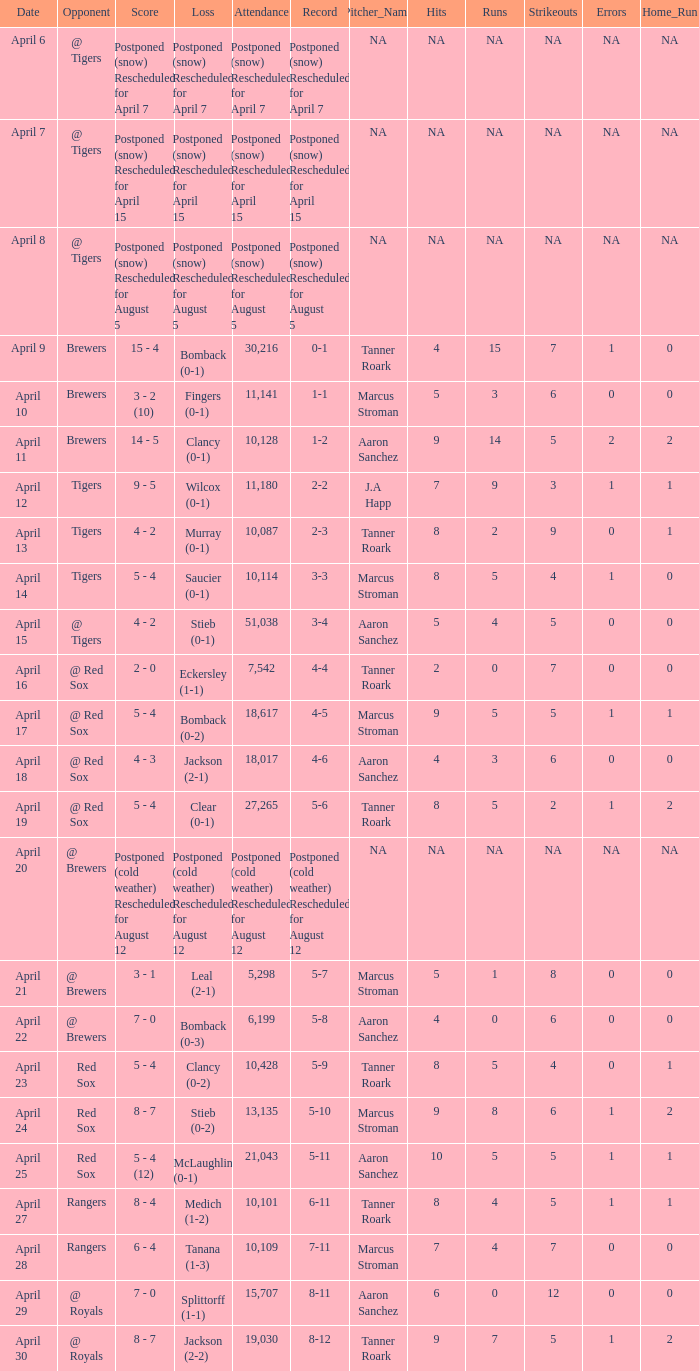Which record is dated April 8? Postponed (snow) Rescheduled for August 5. 